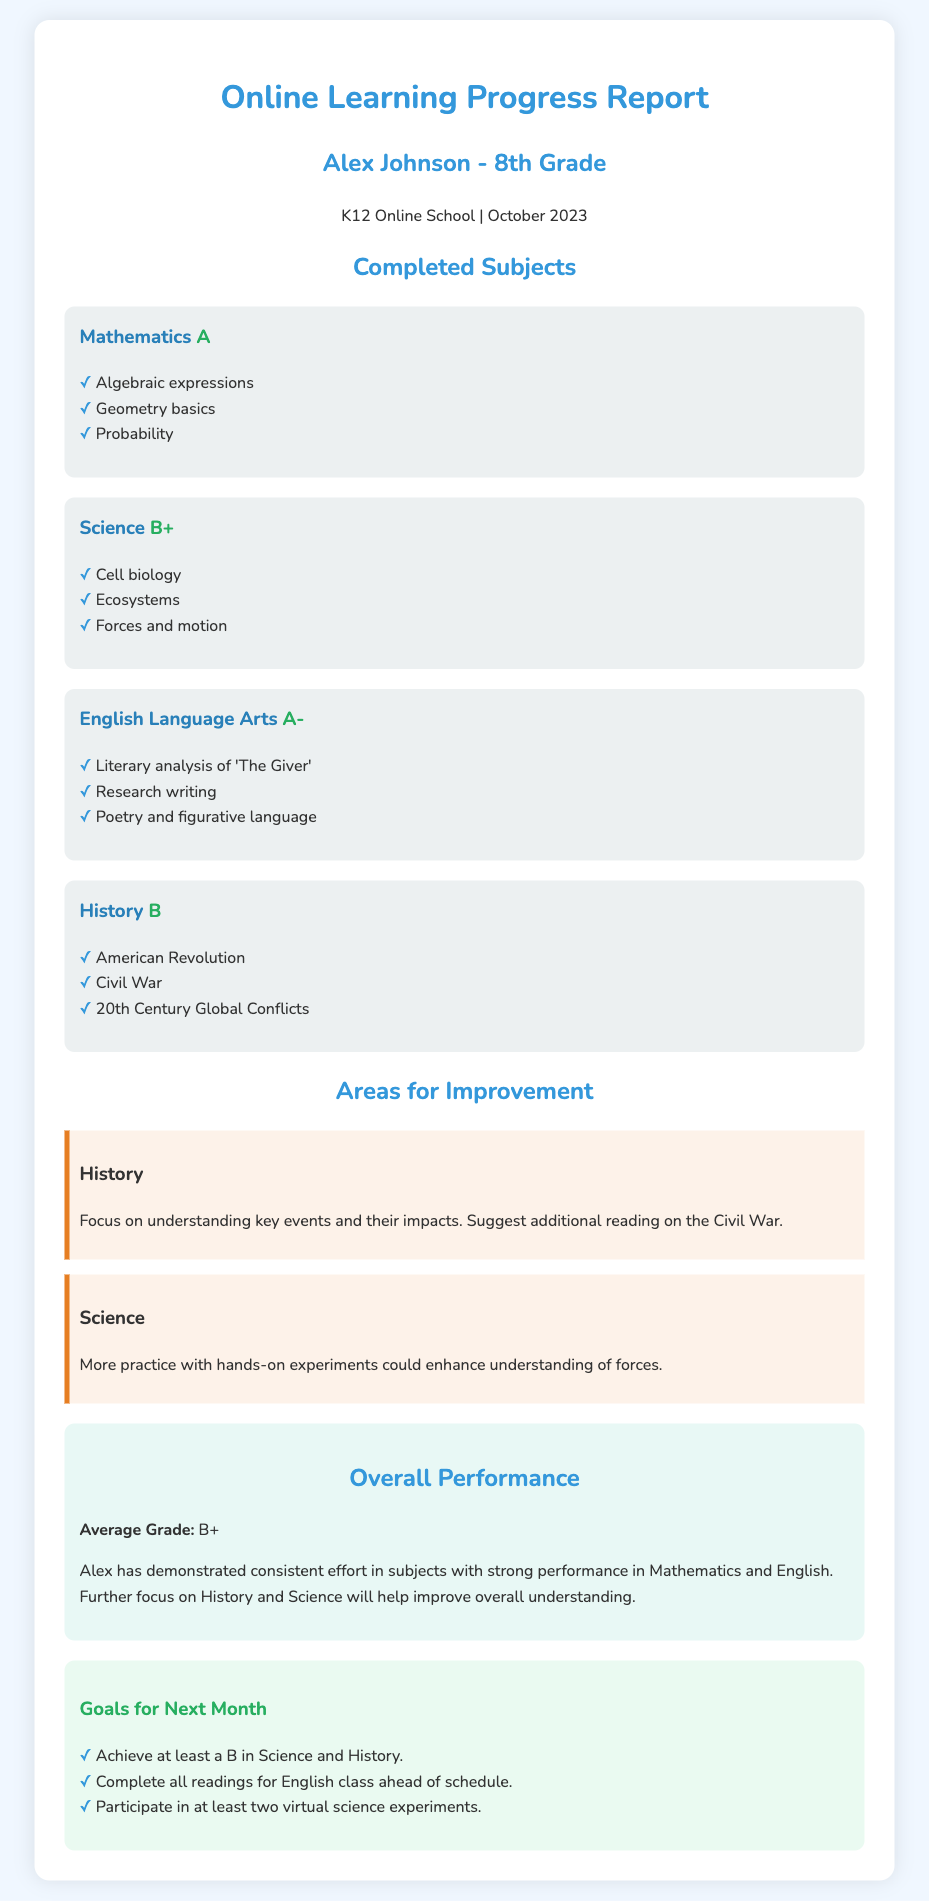What grade did Alex achieve in Mathematics? The document explicitly states that Alex earned an A in Mathematics.
Answer: A Which subject had the lowest grade? By comparing the grades, History received the lowest grade of B.
Answer: B What is the average grade for Alex? The report states the average grade is B+.
Answer: B+ What area in Science needs improvement? The document suggests more practice with hands-on experiments in Science.
Answer: Hands-on experiments What goal does Alex have for Science next month? The report mentions the goal is to participate in at least two virtual science experiments.
Answer: Two virtual science experiments What subject's grade is noted as A-? The document specifies that English Language Arts is graded A-.
Answer: A- Which historical period is part of the History subject completed? The covered topics include the Civil War among others in History.
Answer: Civil War What is the name of the student in this report? The report provides the name Alex Johnson for the student.
Answer: Alex Johnson 